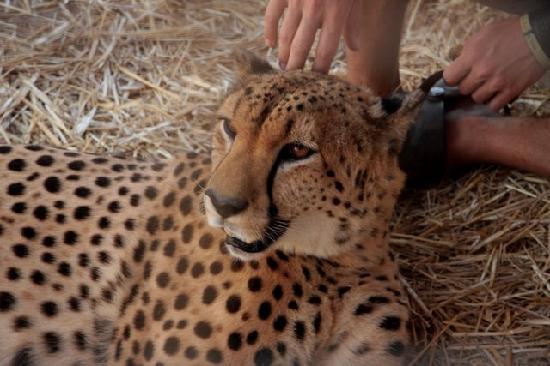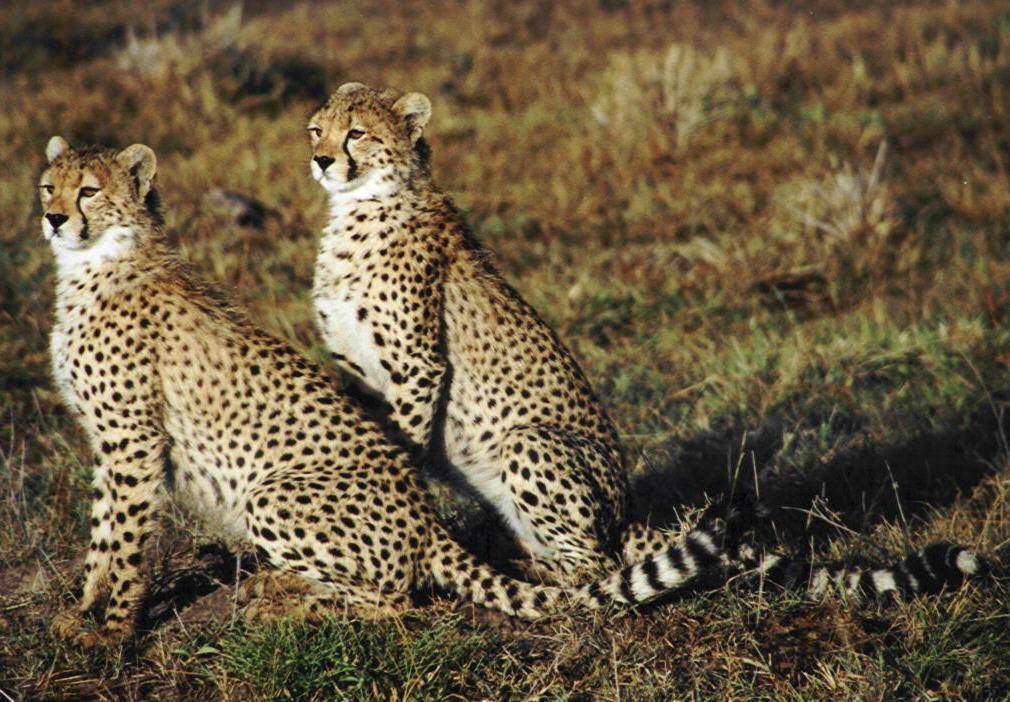The first image is the image on the left, the second image is the image on the right. For the images displayed, is the sentence "In two images two cheetahs are lying next to one another in the brown patchy grass." factually correct? Answer yes or no. No. The first image is the image on the left, the second image is the image on the right. Examine the images to the left and right. Is the description "The left image contains exactly two cheetahs." accurate? Answer yes or no. No. 